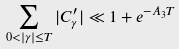<formula> <loc_0><loc_0><loc_500><loc_500>\sum _ { 0 < | \gamma | \leq T } | C _ { \gamma } ^ { \prime } | \ll 1 + e ^ { - A _ { 3 } T }</formula> 